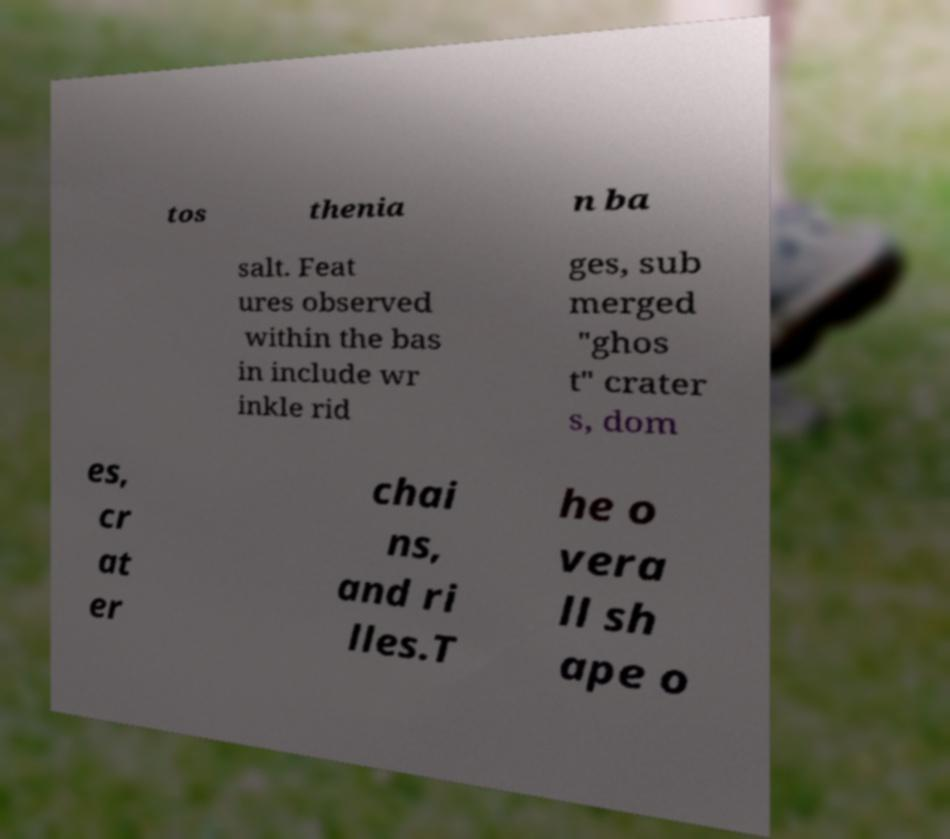There's text embedded in this image that I need extracted. Can you transcribe it verbatim? tos thenia n ba salt. Feat ures observed within the bas in include wr inkle rid ges, sub merged "ghos t" crater s, dom es, cr at er chai ns, and ri lles.T he o vera ll sh ape o 